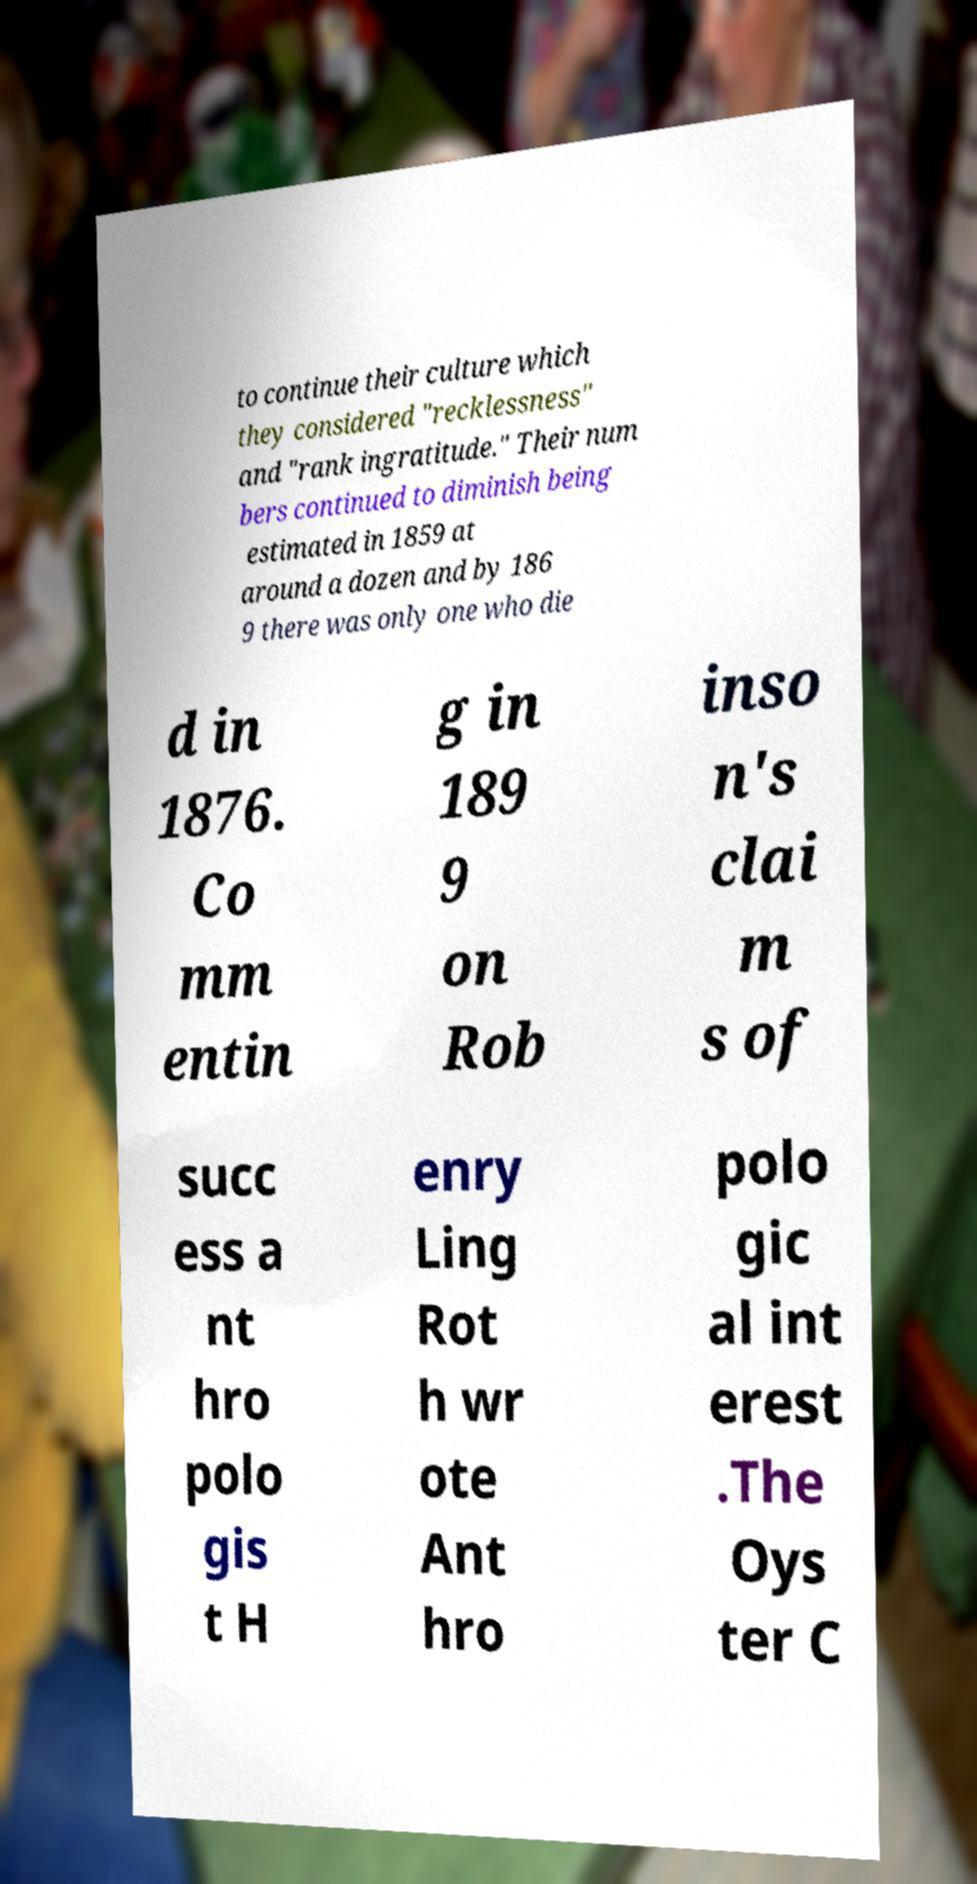Can you read and provide the text displayed in the image?This photo seems to have some interesting text. Can you extract and type it out for me? to continue their culture which they considered "recklessness" and "rank ingratitude." Their num bers continued to diminish being estimated in 1859 at around a dozen and by 186 9 there was only one who die d in 1876. Co mm entin g in 189 9 on Rob inso n's clai m s of succ ess a nt hro polo gis t H enry Ling Rot h wr ote Ant hro polo gic al int erest .The Oys ter C 